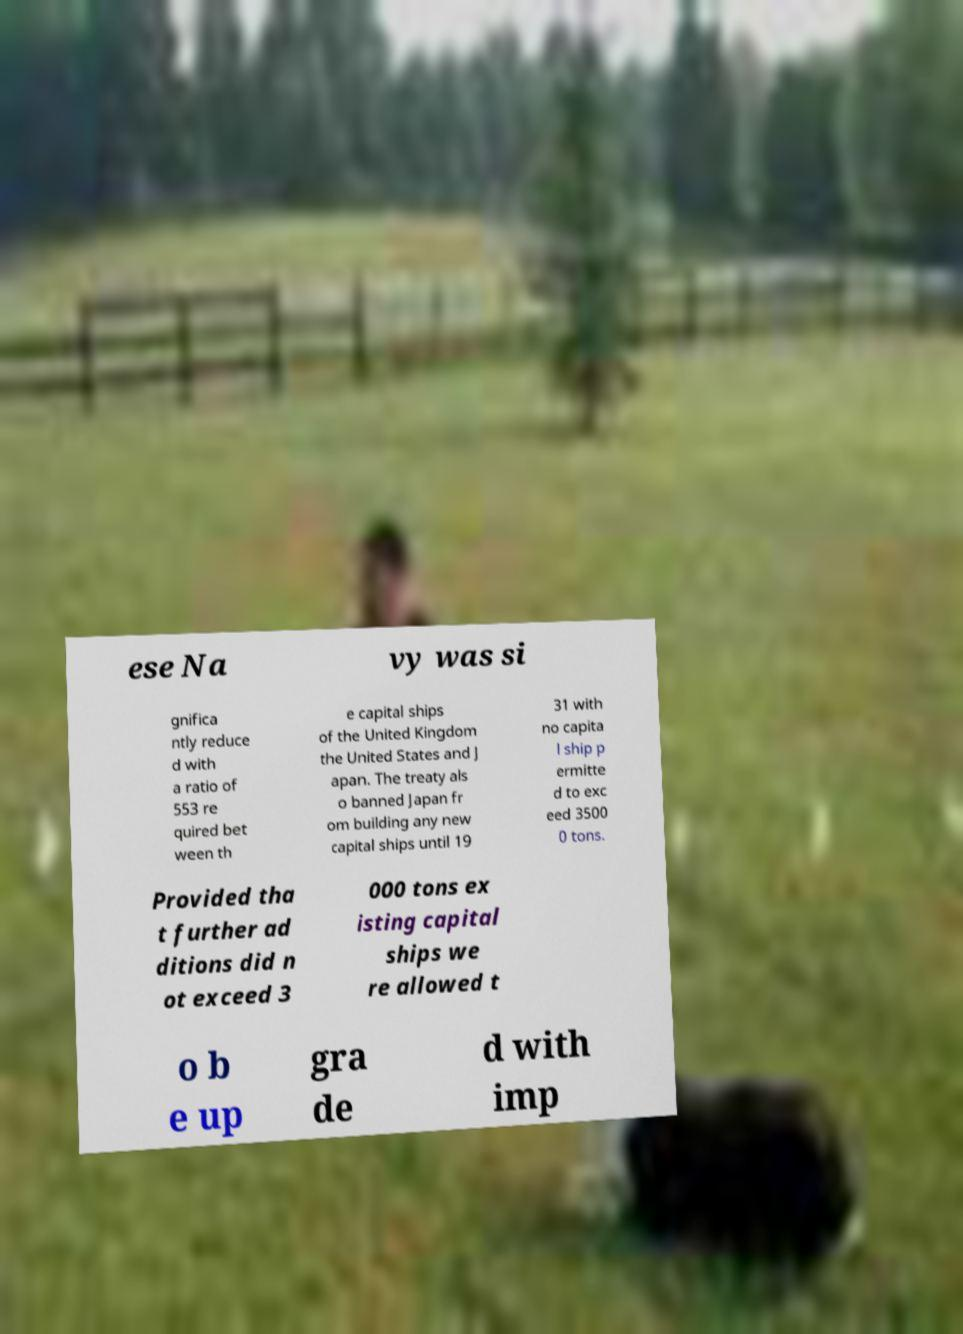Could you assist in decoding the text presented in this image and type it out clearly? ese Na vy was si gnifica ntly reduce d with a ratio of 553 re quired bet ween th e capital ships of the United Kingdom the United States and J apan. The treaty als o banned Japan fr om building any new capital ships until 19 31 with no capita l ship p ermitte d to exc eed 3500 0 tons. Provided tha t further ad ditions did n ot exceed 3 000 tons ex isting capital ships we re allowed t o b e up gra de d with imp 